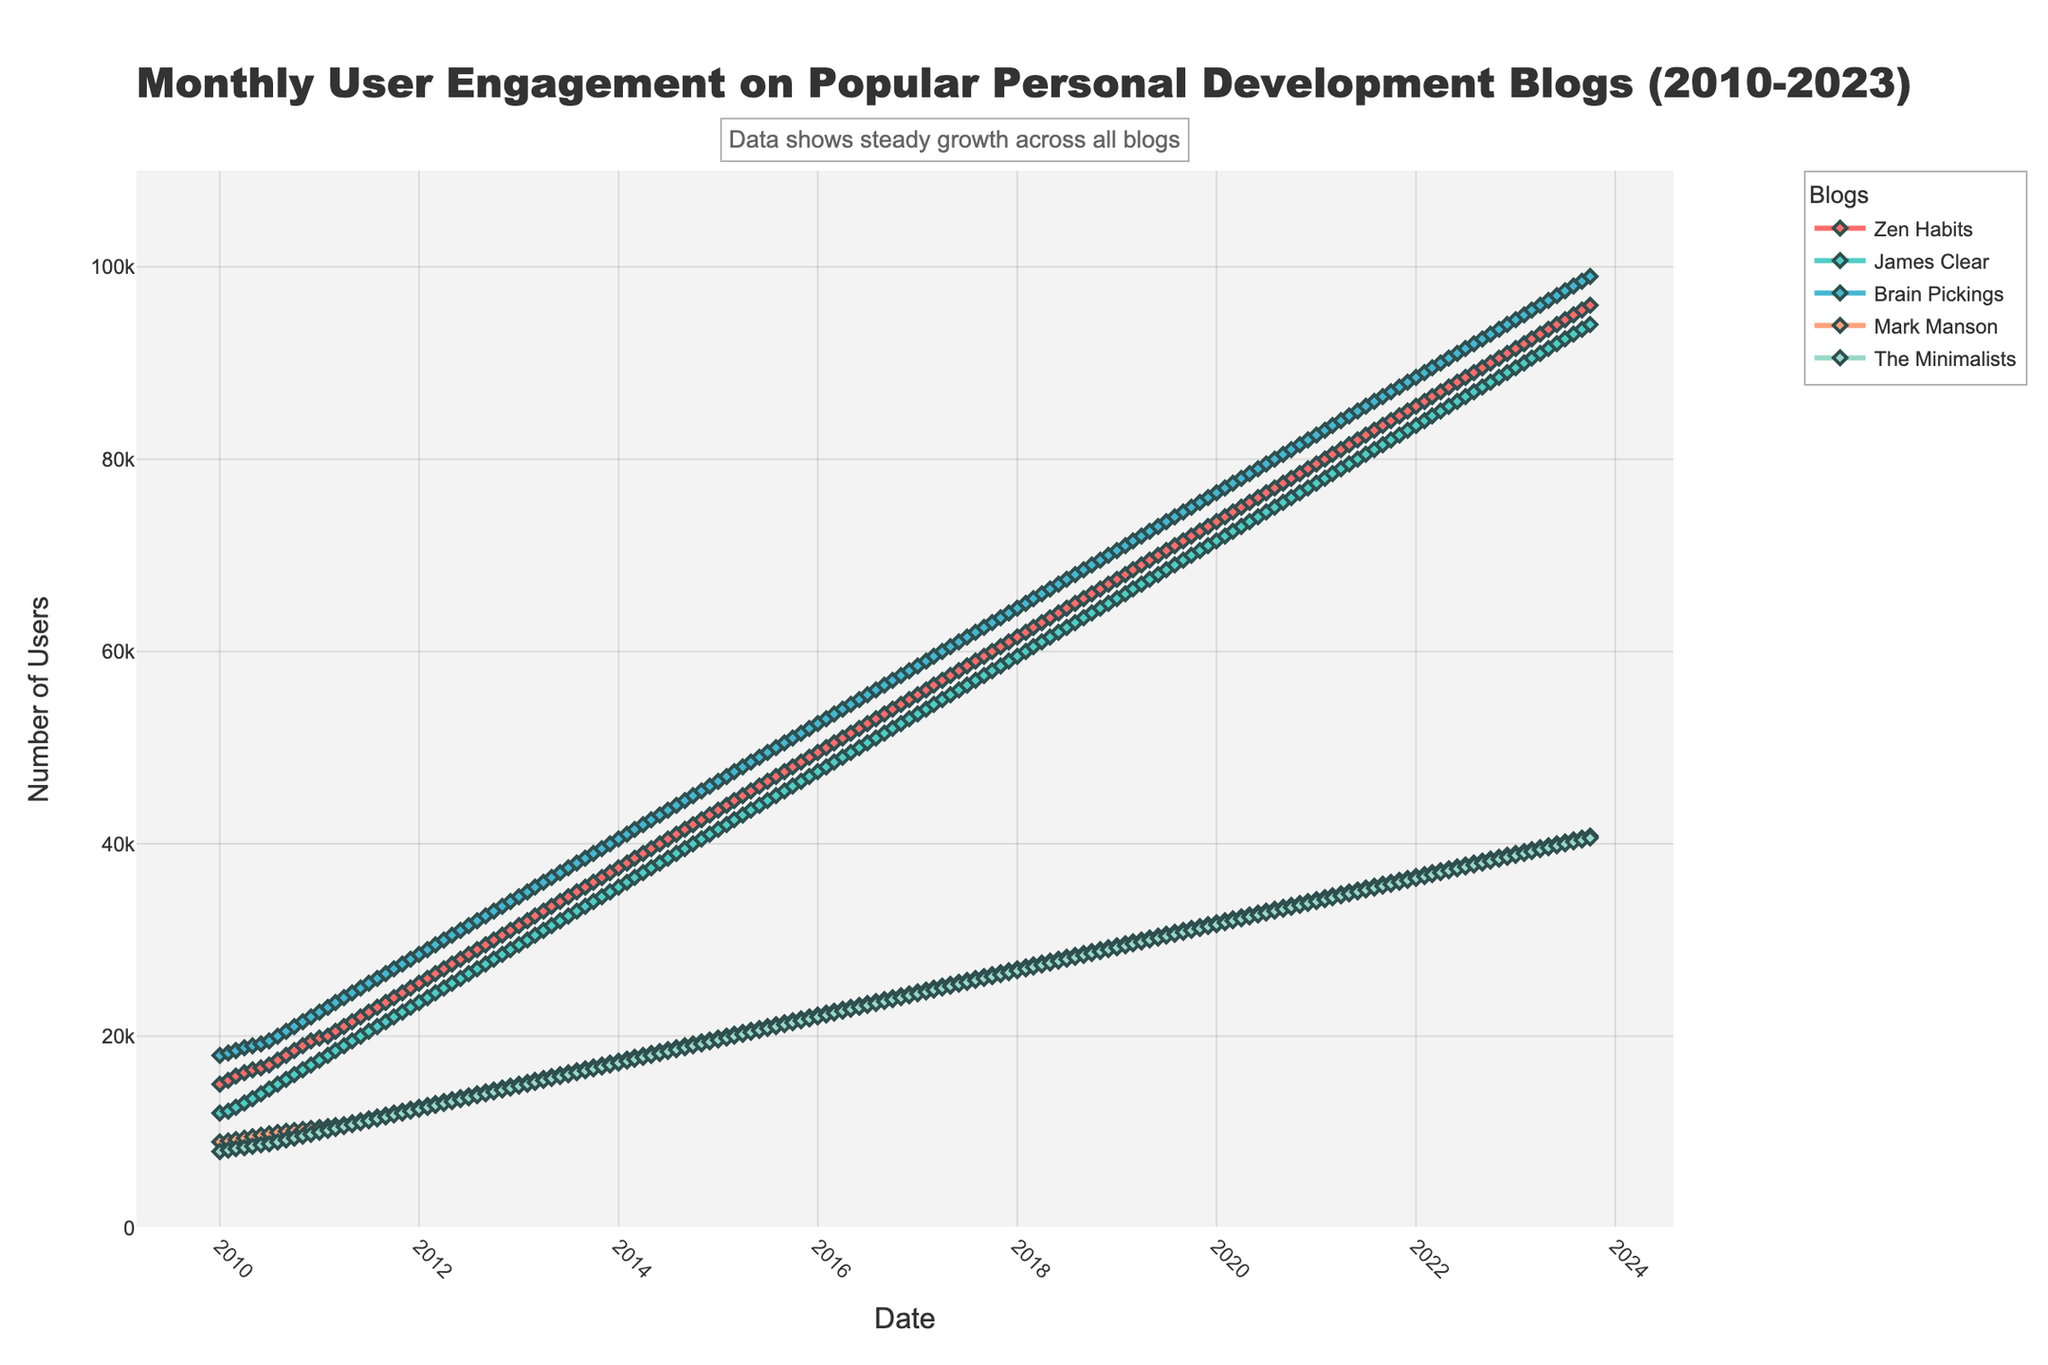How many blogs are represented in the figure? The figure shows engagement data for five blogs, each indicated by a unique color.
Answer: 5 Which blog has the highest user engagement in October 2023? In October 2023, "Brain Pickings" displays the highest number of users, seen at the topmost line on the plot.
Answer: Brain Pickings What is the overall trend for user engagement on Mark Manson's blog from 2010 to 2023? Mark Manson's blog shows a consistent upward trend in user engagement from 9,000 users in January 2010 to 40,800 users in October 2023.
Answer: Upward Which months show the highest increase in users for Zen Habits from 2011? Comparing the monthly increments, the highest increases for Zen Habits are typically seen in the months of March and April each year.
Answer: March and April From 2010 to 2023, which blog had the fastest growth in user engagement? By observing the slopes of the lines, "James Clear" exhibits one of the steepest upward trajectories, indicating the fastest growth among all blogs.
Answer: James Clear Is there a blog whose engagement almost doubled from the start to the end of the timeline? Yes, "Brain Pickings" shows a significant increase, starting from 18,000 users in January 2010 to 99,000 users in October 2023, almost doubling its user engagement.
Answer: Brain Pickings During which year did The Minimalists experience the most rapid increase in user engagement? Observing the slope of the line for The Minimalists, the most rapid increase seems to occur around 2016-2017, where the line is the steepest.
Answer: 2016-2017 What is the combined user engagement for all blogs in January 2012? Sum up the user engagement figures for January 2012 across all blogs: Zen Habits: 25,500, James Clear: 23,500, Brain Pickings: 28,500, Mark Manson: 12,600, The Minimalists: 12,400. Total = 25,500 + 23,500 + 28,500 + 12,600 + 12,400 = 102,500.
Answer: 102,500 By how much did user engagement on Zen Habits increase from January 2010 to October 2023? The initial number of users in January 2010 was 15,000 and in October 2023 the number reached 96,000. The increase is 96,000 - 15,000 = 81,000.
Answer: 81,000 How does the trend in user engagement for The Minimalists compare to that of James Clear? Both The Minimalists and James Clear show consistent upward trends, but the slope for James Clear is steeper, indicating a faster rate of increase in user engagement compared to The Minimalists.
Answer: James Clear has a faster increase 